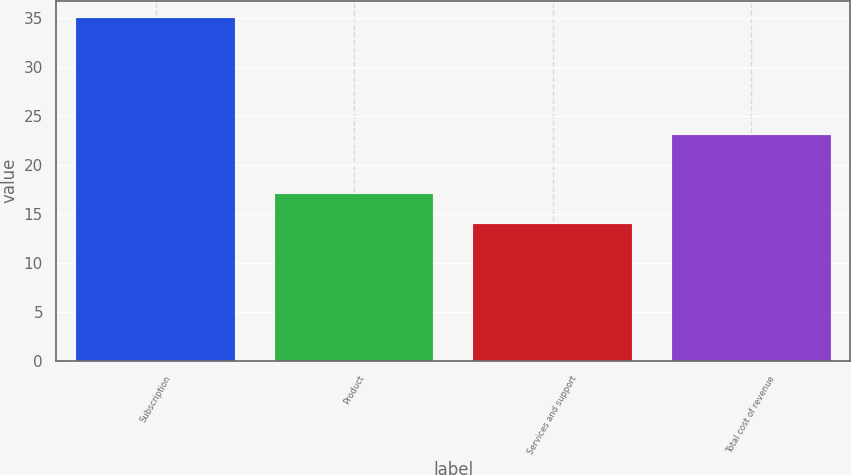<chart> <loc_0><loc_0><loc_500><loc_500><bar_chart><fcel>Subscription<fcel>Product<fcel>Services and support<fcel>Total cost of revenue<nl><fcel>35<fcel>17<fcel>14<fcel>23<nl></chart> 